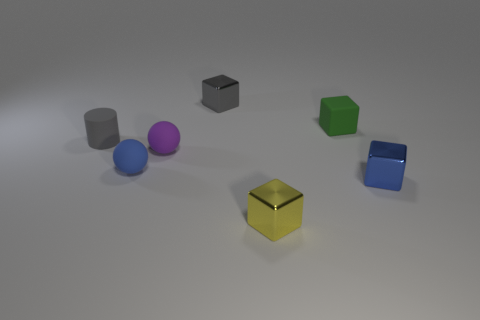There is a tiny thing that is the same color as the small matte cylinder; what shape is it?
Offer a very short reply. Cube. Is the number of tiny metallic blocks in front of the tiny blue block greater than the number of small blue cubes left of the purple sphere?
Offer a terse response. Yes. Do the small metal object that is behind the blue shiny object and the small rubber cylinder have the same color?
Make the answer very short. Yes. Are there any other things that have the same color as the tiny rubber cylinder?
Make the answer very short. Yes. Is the number of metallic objects in front of the small blue matte sphere greater than the number of small yellow rubber cubes?
Ensure brevity in your answer.  Yes. Is the size of the yellow metal thing the same as the green cube?
Provide a succinct answer. Yes. There is a tiny yellow thing that is the same shape as the gray metallic thing; what is its material?
Offer a terse response. Metal. How many red things are tiny things or blocks?
Provide a short and direct response. 0. There is a blue object that is left of the yellow shiny cube; what material is it?
Offer a very short reply. Rubber. Is the number of small shiny blocks greater than the number of yellow objects?
Keep it short and to the point. Yes. 